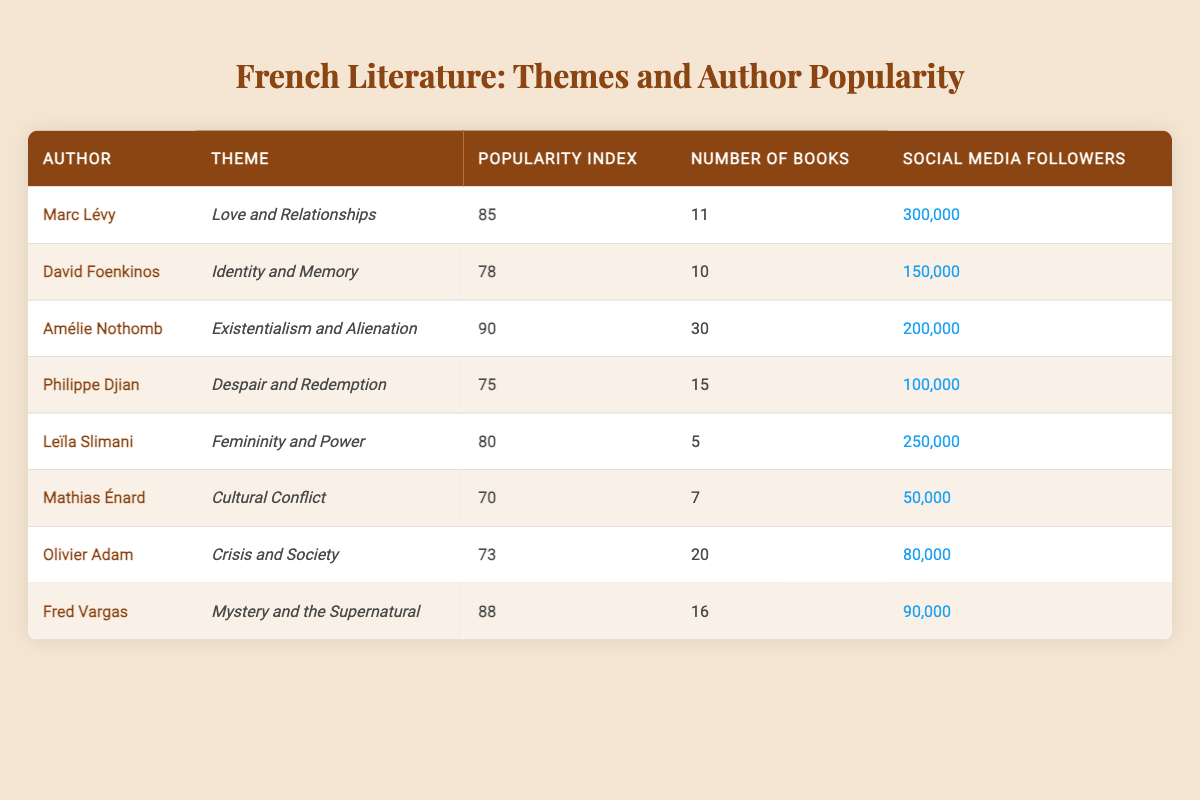What is the highest popularity index among the authors? The highest popularity index listed in the table is for Amélie Nothomb, which is 90. I found this by scanning the "Popularity Index" column for the maximum value.
Answer: 90 Which author has the most social media followers? Among the authors listed, Marc Lévy has the highest number of social media followers, with 300,000. This was determined by comparing all the values in the "Social Media Followers" column.
Answer: Marc Lévy How many authors have a popularity index above 80? Looking at the "Popularity Index" column, I see that Amélie Nothomb (90), Fred Vargas (88), and Marc Lévy (85) all have values above 80. This counts to three authors in total.
Answer: 3 What is the average popularity index of the authors listed in the table? To calculate the average, I summed all the popularity indices (85 + 78 + 90 + 75 + 80 + 70 + 73 + 88 = 639) and divided by the number of authors (8). Thus, the average is 639/8 = 79.875.
Answer: 79.875 Is it true that Leïla Slimani has more social media followers than Amélie Nothomb? By comparing the social media follower counts, Leïla Slimani has 250,000 followers while Amélie Nothomb has 200,000. Therefore, it is true that Leïla Slimani has more followers.
Answer: Yes Which theme appears most frequently among the authors? Upon checking the themes, they are all distinct for each author without repetition. Each author has a unique theme associated with them, so there isn't a most frequent theme.
Answer: None (all themes are unique) What is the difference in social media followers between Marc Lévy and Mathias Énard? Marc Lévy has 300,000 followers, while Mathias Énard has 50,000. The difference is calculated by subtracting Mathias Énard's followers from Marc Lévy's: 300,000 - 50,000 = 250,000.
Answer: 250,000 Does the author with the lowest popularity index have the highest number of books? The author with the lowest popularity index is Mathias Énard, with a score of 70, and he has published 7 books. The author with the highest number of books is Amélie Nothomb, who has 30 books but a higher popularity index. Therefore, it is false.
Answer: No 